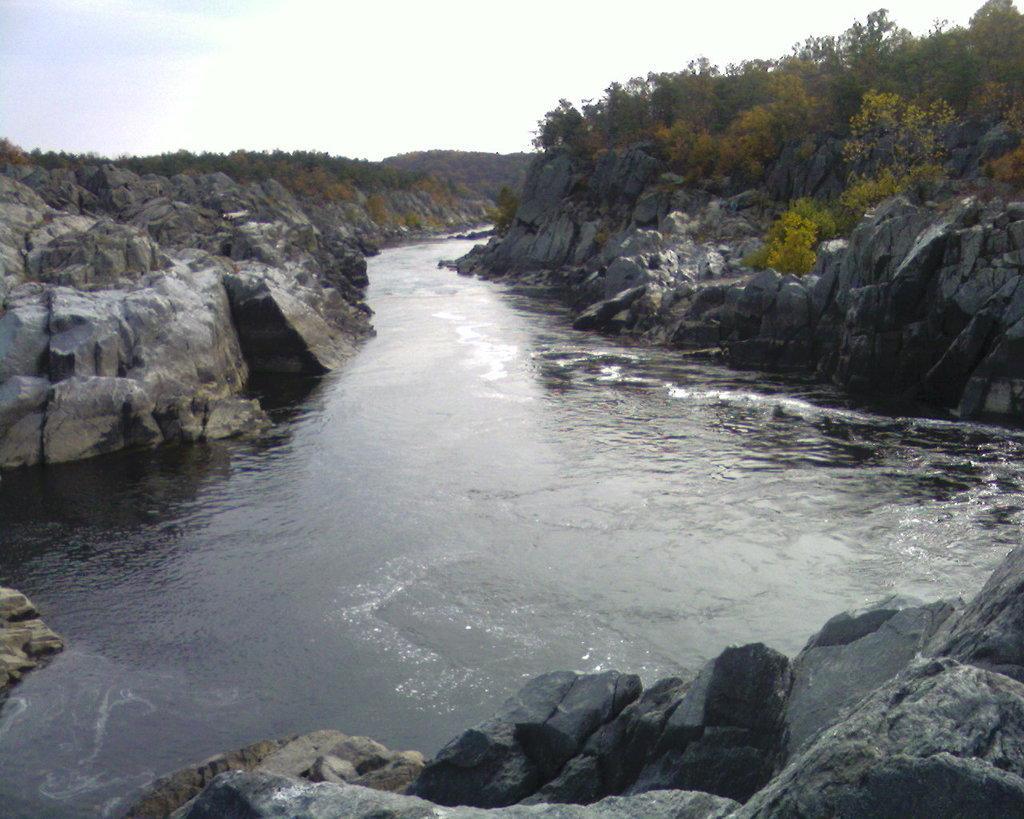In one or two sentences, can you explain what this image depicts? This image is clicked outside. There are trees on the right side. There is water in the middle. There is sky at the top. 